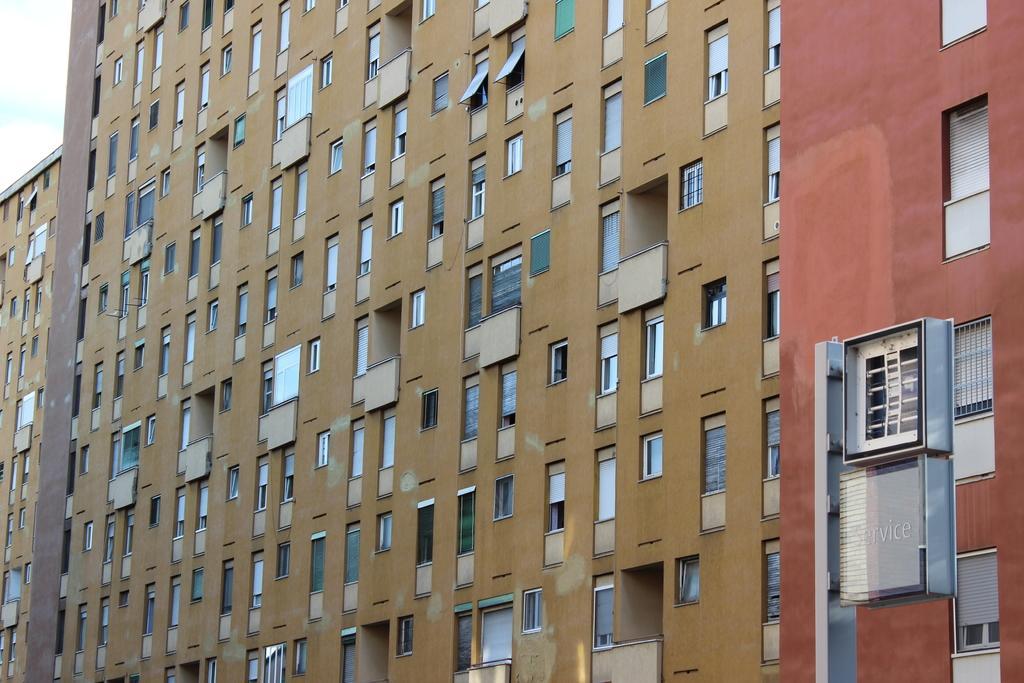Can you describe this image briefly? In this image in the middle, there is a building. It consists of many windows, glasses. At the bottom there is a text. In the background there are sky and clouds. 